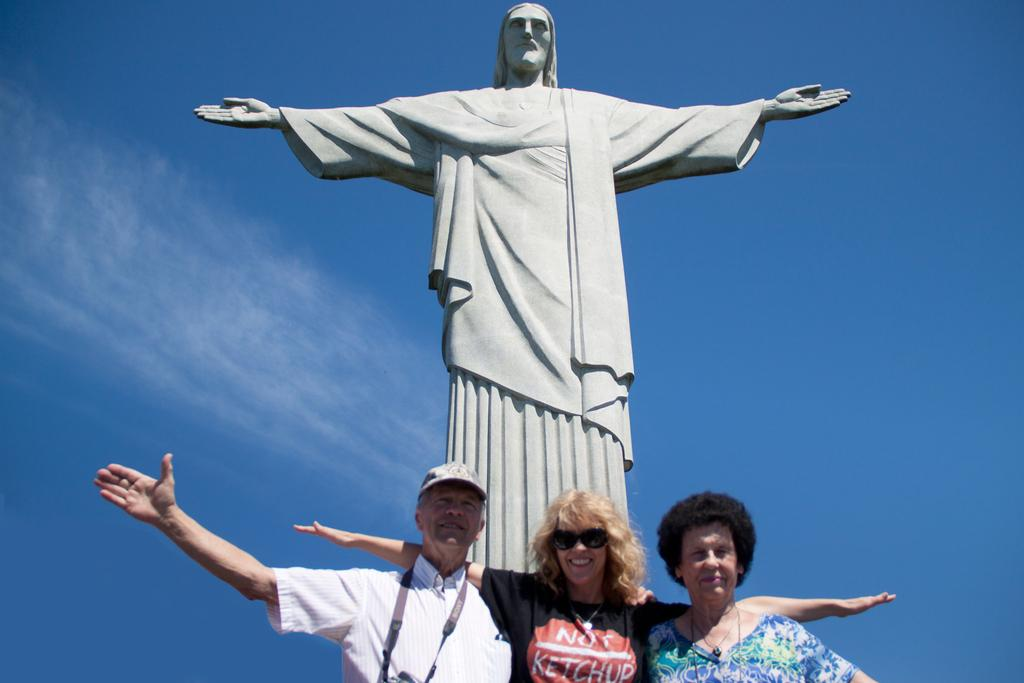How many people are present in the image? There are three people in the image. What is the facial expression of the middle person? The middle person is smiling. What accessory is the middle person wearing? The middle person is wearing spectacles. What can be seen in the background of the image? There is a statue and clouds visible in the background of the image. What type of muscle is being flexed by the person on the left in the image? There is no person on the left flexing a muscle in the image; there are only three people, and none of them are flexing a muscle. 